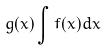Convert formula to latex. <formula><loc_0><loc_0><loc_500><loc_500>g ( x ) \int f ( x ) d x</formula> 